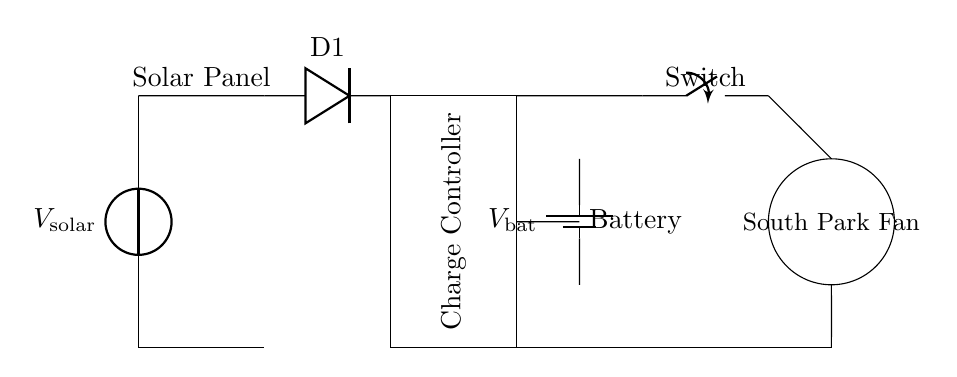What component converts solar energy? The solar panel is responsible for converting solar energy into electrical energy. It is depicted at the beginning of the circuit diagram.
Answer: Solar Panel What does the switch control? The switch controls the flow of electricity to the fan, allowing it to be turned on or off. Its position in the circuit indicates that it can interrupt current flow to the fan.
Answer: Fan What is the required type of battery? The battery is labeled as a battery unit in the circuit and stores energy that can be released to power the fan when needed, but the exact type is not given.
Answer: Not specified Where does the diode connect in the circuit? The diode is placed between the solar panel and the charge controller, ensuring current flows in the correct direction and prevents backflow into the solar panel.
Answer: Between solar panel and charge controller How does the charge controller work? The charge controller regulates the voltage and current coming from the solar panel to the battery, preventing overcharging and managing energy distribution.
Answer: Regulates charging What is the main purpose of this entire circuit? The primary purpose of this circuit is to provide a sustainable way to power a fan using solar energy, making it environmentally friendly.
Answer: Power a fan What is the current flow direction for charging? The current flows from the solar panel to the charge controller and then to the battery for charging, indicated by the connections in the circuit diagram.
Answer: Solar panel to battery 